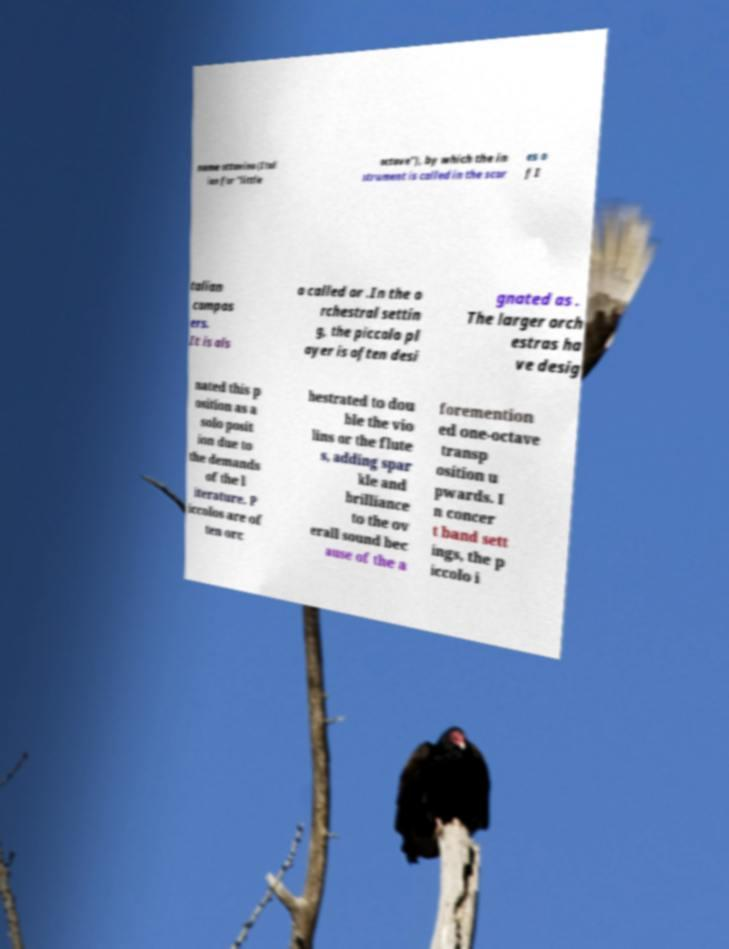Can you read and provide the text displayed in the image?This photo seems to have some interesting text. Can you extract and type it out for me? name ottavino (Ital ian for "little octave"), by which the in strument is called in the scor es o f I talian compos ers. It is als o called or .In the o rchestral settin g, the piccolo pl ayer is often desi gnated as . The larger orch estras ha ve desig nated this p osition as a solo posit ion due to the demands of the l iterature. P iccolos are of ten orc hestrated to dou ble the vio lins or the flute s, adding spar kle and brilliance to the ov erall sound bec ause of the a foremention ed one-octave transp osition u pwards. I n concer t band sett ings, the p iccolo i 